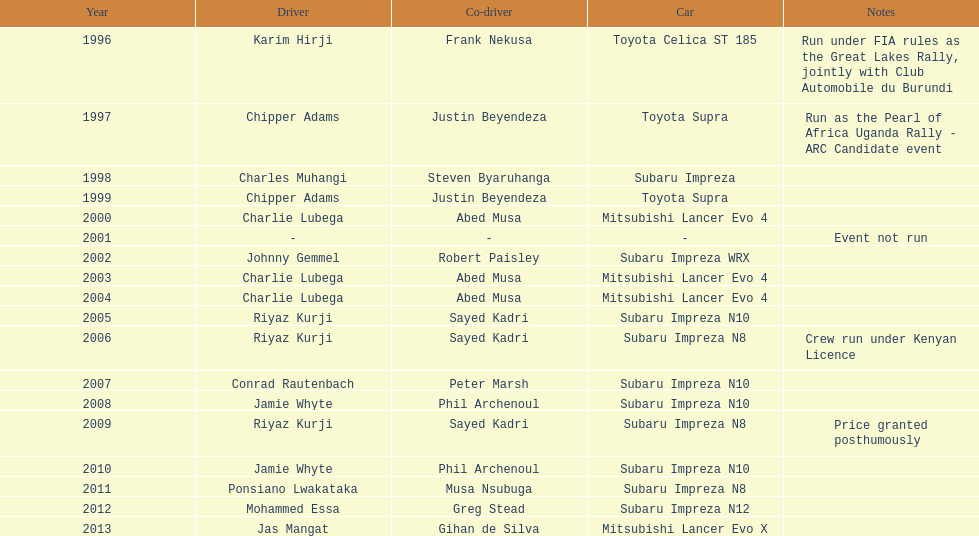How many drivers won at least twice? 4. 